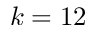<formula> <loc_0><loc_0><loc_500><loc_500>k = 1 2</formula> 